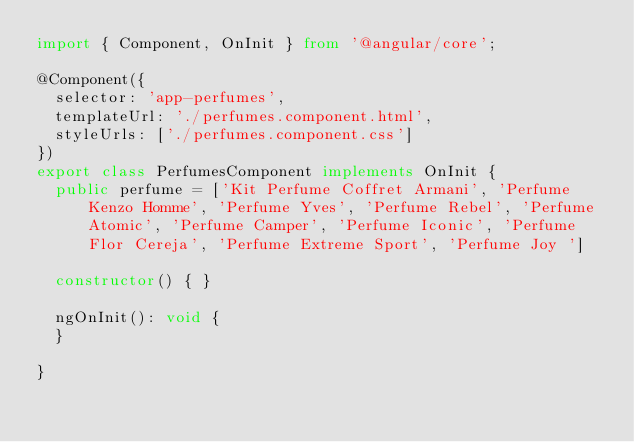<code> <loc_0><loc_0><loc_500><loc_500><_TypeScript_>import { Component, OnInit } from '@angular/core';

@Component({
  selector: 'app-perfumes',
  templateUrl: './perfumes.component.html',
  styleUrls: ['./perfumes.component.css']
})
export class PerfumesComponent implements OnInit {
  public perfume = ['Kit Perfume Coffret Armani', 'Perfume Kenzo Homme', 'Perfume Yves', 'Perfume Rebel', 'Perfume Atomic', 'Perfume Camper', 'Perfume Iconic', 'Perfume Flor Cereja', 'Perfume Extreme Sport', 'Perfume Joy ']

  constructor() { }

  ngOnInit(): void {
  }

}
</code> 